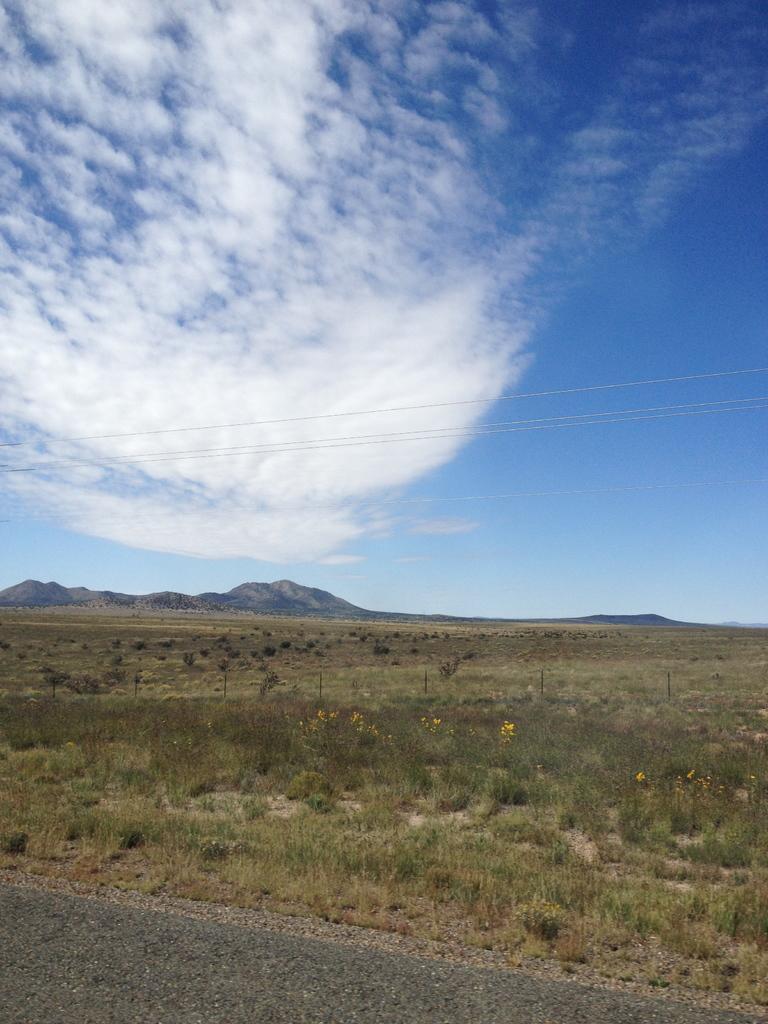Can you describe this image briefly? In this image there is grassland, in the background there is the mountain and the sky. 